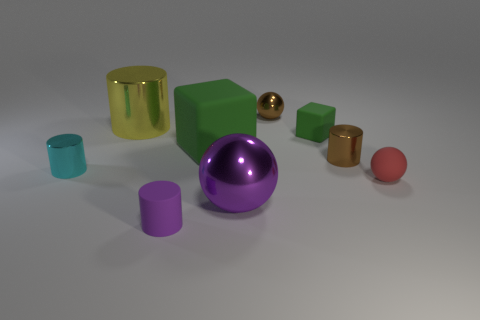Subtract 1 cylinders. How many cylinders are left? 3 Subtract all gray cylinders. Subtract all gray spheres. How many cylinders are left? 4 Add 1 big yellow metallic cylinders. How many objects exist? 10 Subtract all spheres. How many objects are left? 6 Add 2 tiny red matte balls. How many tiny red matte balls are left? 3 Add 9 small green metallic spheres. How many small green metallic spheres exist? 9 Subtract 0 gray spheres. How many objects are left? 9 Subtract all large yellow spheres. Subtract all small brown cylinders. How many objects are left? 8 